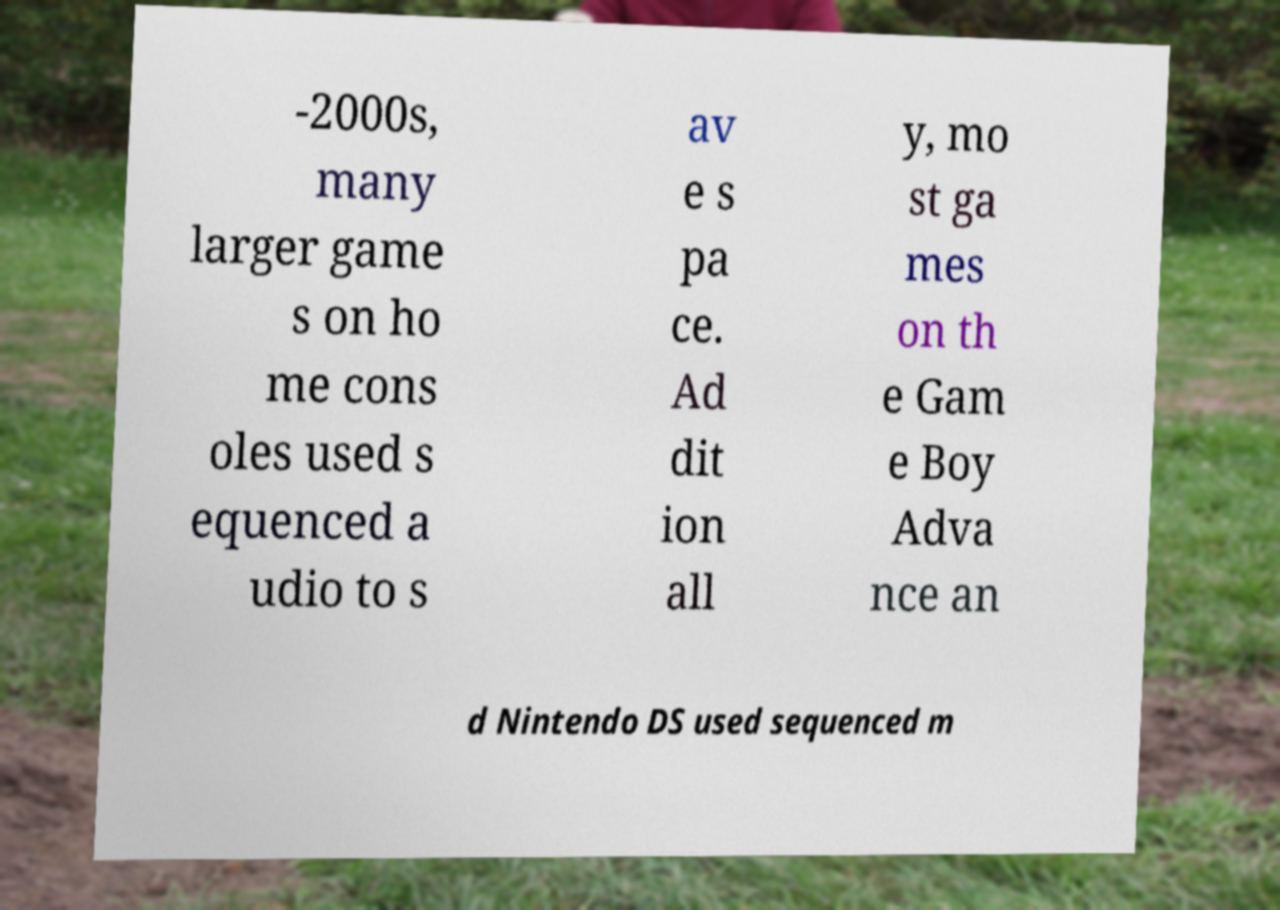What messages or text are displayed in this image? I need them in a readable, typed format. -2000s, many larger game s on ho me cons oles used s equenced a udio to s av e s pa ce. Ad dit ion all y, mo st ga mes on th e Gam e Boy Adva nce an d Nintendo DS used sequenced m 